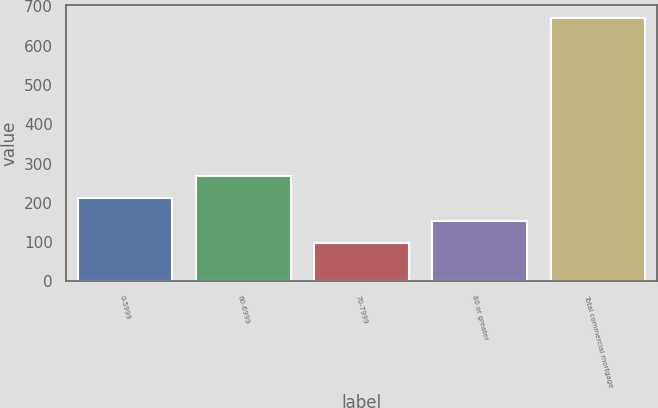Convert chart. <chart><loc_0><loc_0><loc_500><loc_500><bar_chart><fcel>0-5999<fcel>60-6999<fcel>70-7999<fcel>80 or greater<fcel>Total commercial mortgage<nl><fcel>211.6<fcel>268.9<fcel>97<fcel>154.3<fcel>670<nl></chart> 